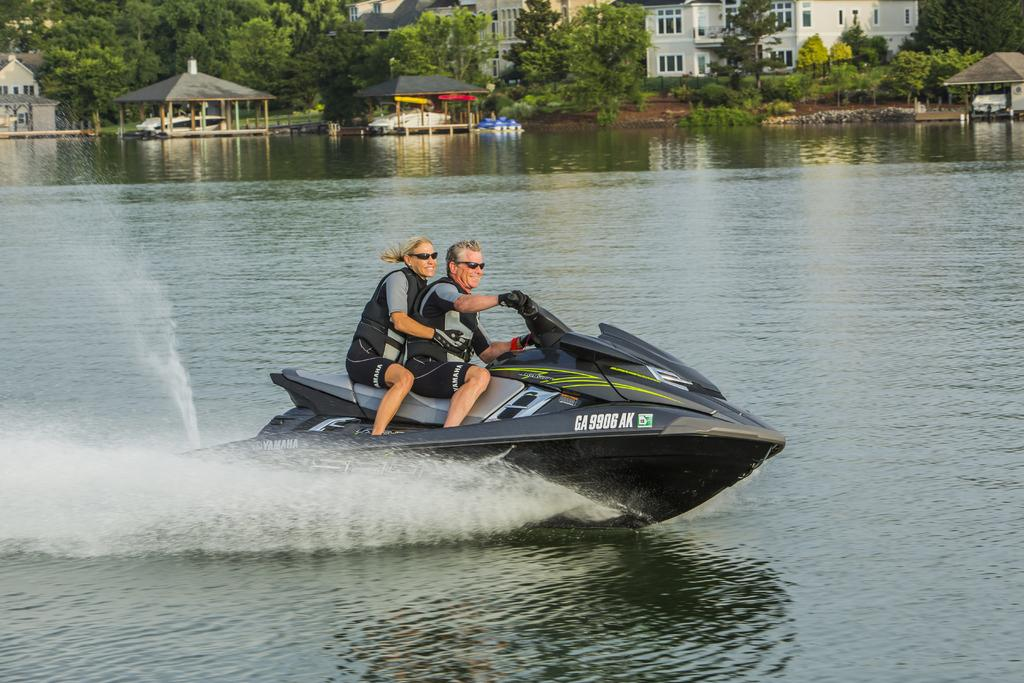How many people are on the speedboat in the image? There are two people sitting on the speedboat in the image. What is the color of the speedboat? The speedboat is in black and ash color. What can be seen in the background of the image? Buildings, windows, trees, and sheds are visible in the background. What is the primary element surrounding the speedboat? Water is visible in the image. What type of toy can be seen floating in the water near the speedboat? There is no toy visible in the water near the speedboat in the image. How many clovers are growing on the speedboat? There are no clovers present on the speedboat in the image. 